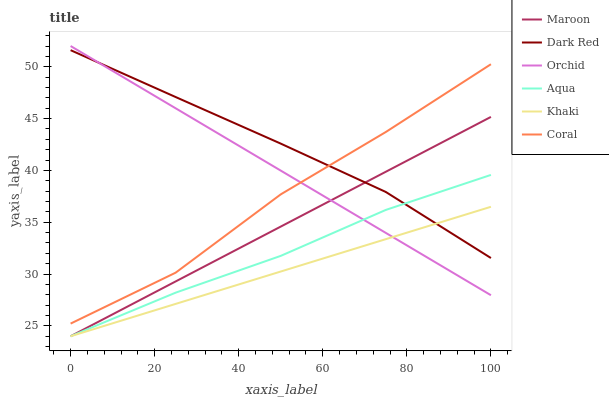Does Khaki have the minimum area under the curve?
Answer yes or no. Yes. Does Dark Red have the maximum area under the curve?
Answer yes or no. Yes. Does Coral have the minimum area under the curve?
Answer yes or no. No. Does Coral have the maximum area under the curve?
Answer yes or no. No. Is Maroon the smoothest?
Answer yes or no. Yes. Is Coral the roughest?
Answer yes or no. Yes. Is Dark Red the smoothest?
Answer yes or no. No. Is Dark Red the roughest?
Answer yes or no. No. Does Khaki have the lowest value?
Answer yes or no. Yes. Does Coral have the lowest value?
Answer yes or no. No. Does Orchid have the highest value?
Answer yes or no. Yes. Does Dark Red have the highest value?
Answer yes or no. No. Is Maroon less than Coral?
Answer yes or no. Yes. Is Coral greater than Khaki?
Answer yes or no. Yes. Does Orchid intersect Coral?
Answer yes or no. Yes. Is Orchid less than Coral?
Answer yes or no. No. Is Orchid greater than Coral?
Answer yes or no. No. Does Maroon intersect Coral?
Answer yes or no. No. 